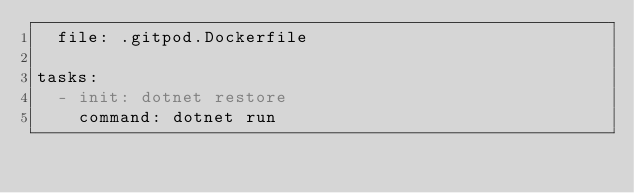<code> <loc_0><loc_0><loc_500><loc_500><_YAML_>  file: .gitpod.Dockerfile

tasks:
  - init: dotnet restore
    command: dotnet run
</code> 